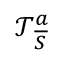<formula> <loc_0><loc_0><loc_500><loc_500>\mathcal { T } _ { \overline { S } } ^ { a }</formula> 